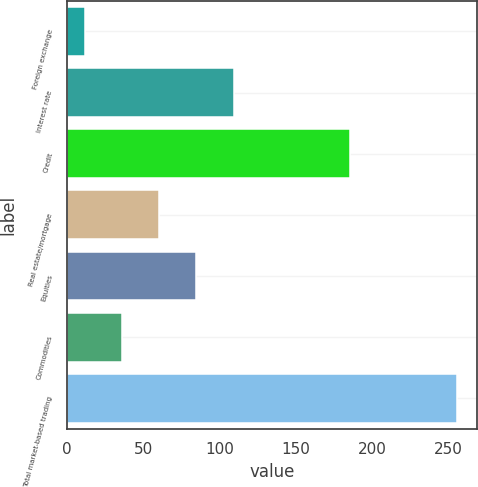Convert chart to OTSL. <chart><loc_0><loc_0><loc_500><loc_500><bar_chart><fcel>Foreign exchange<fcel>Interest rate<fcel>Credit<fcel>Real estate/mortgage<fcel>Equities<fcel>Commodities<fcel>Total market-based trading<nl><fcel>11.7<fcel>109.3<fcel>185.2<fcel>60.5<fcel>84.9<fcel>36.1<fcel>255.7<nl></chart> 